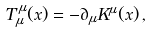<formula> <loc_0><loc_0><loc_500><loc_500>T _ { \mu } ^ { \, \mu } ( x ) = - \partial _ { \mu } K ^ { \mu } ( x ) \, ,</formula> 